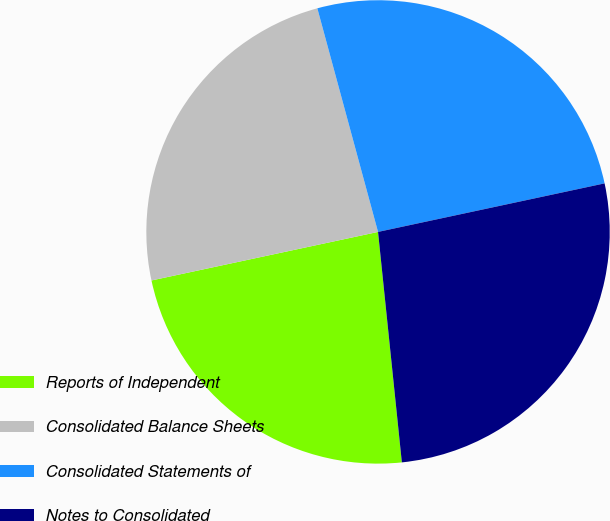<chart> <loc_0><loc_0><loc_500><loc_500><pie_chart><fcel>Reports of Independent<fcel>Consolidated Balance Sheets<fcel>Consolidated Statements of<fcel>Notes to Consolidated<nl><fcel>23.28%<fcel>24.14%<fcel>25.86%<fcel>26.72%<nl></chart> 